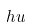<formula> <loc_0><loc_0><loc_500><loc_500>h u</formula> 